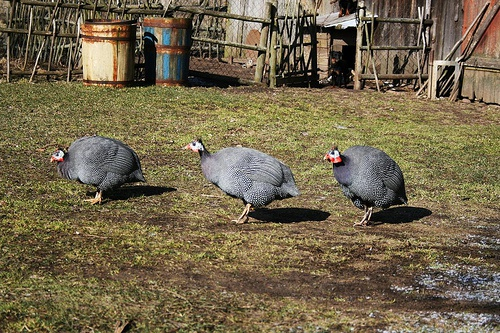Describe the objects in this image and their specific colors. I can see bird in tan, darkgray, gray, lightgray, and black tones, bird in tan, gray, black, and darkgray tones, and bird in tan, gray, black, and darkgray tones in this image. 